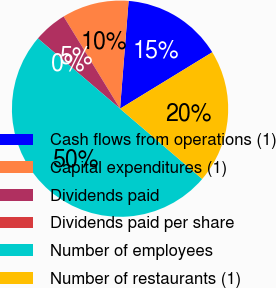<chart> <loc_0><loc_0><loc_500><loc_500><pie_chart><fcel>Cash flows from operations (1)<fcel>Capital expenditures (1)<fcel>Dividends paid<fcel>Dividends paid per share<fcel>Number of employees<fcel>Number of restaurants (1)<nl><fcel>15.0%<fcel>10.0%<fcel>5.0%<fcel>0.0%<fcel>50.0%<fcel>20.0%<nl></chart> 